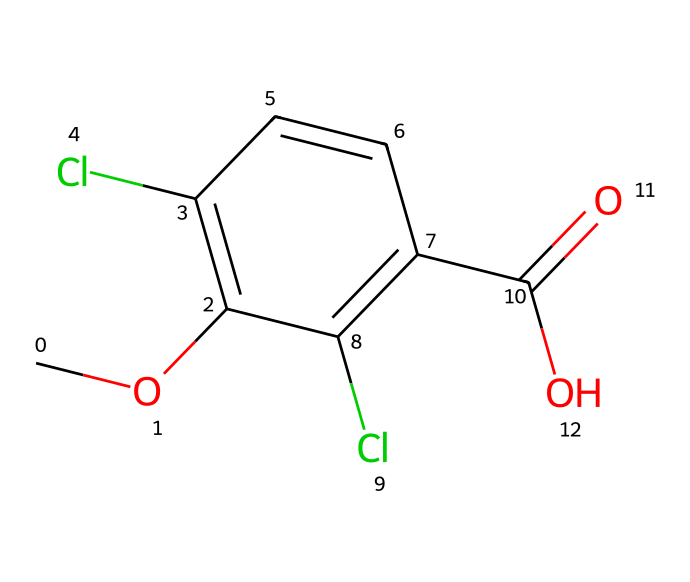What is the molecular formula of dicamba? To derive the molecular formula, count the number of each type of atom in the chemical structure. The structure contains 10 carbon atoms, 9 hydrogen atoms, 2 chlorine atoms, and 2 oxygen atoms. Therefore, the molecular formula is C10H9Cl2O2.
Answer: C10H9Cl2O2 How many chlorine atoms are present in this compound? By examining the chemical structure, we can see that there are two chlorine atoms attached to the benzene ring, indicated by the Cl symbols.
Answer: 2 Is dicamba considered a selective herbicide? Dicamba is known to selectively target certain broadleaf weeds without harming surrounding grasses, which is a characteristic of selective herbicides.
Answer: yes What functional groups are present in dicamba? The structure of dicamba shows a carboxylic acid group (–COOH) and an ether group (–O–C–). These groups play a crucial role in its chemical behavior and herbicidal properties.
Answer: carboxylic acid, ether What property of dicamba can be inferred from the presence of the carboxylic acid group? The presence of a carboxylic acid group suggests that dicamba has acidic properties, which can affect its solubility in water and soil interactions.
Answer: acidic How does the presence of chlorine atoms affect the herbicidal activity of dicamba? Chlorine atoms in the structure often enhance the herbicidal activity of compounds by increasing their stability and selectivity towards target weeds, making dicamba more effective against certain species.
Answer: enhances stability and selectivity 